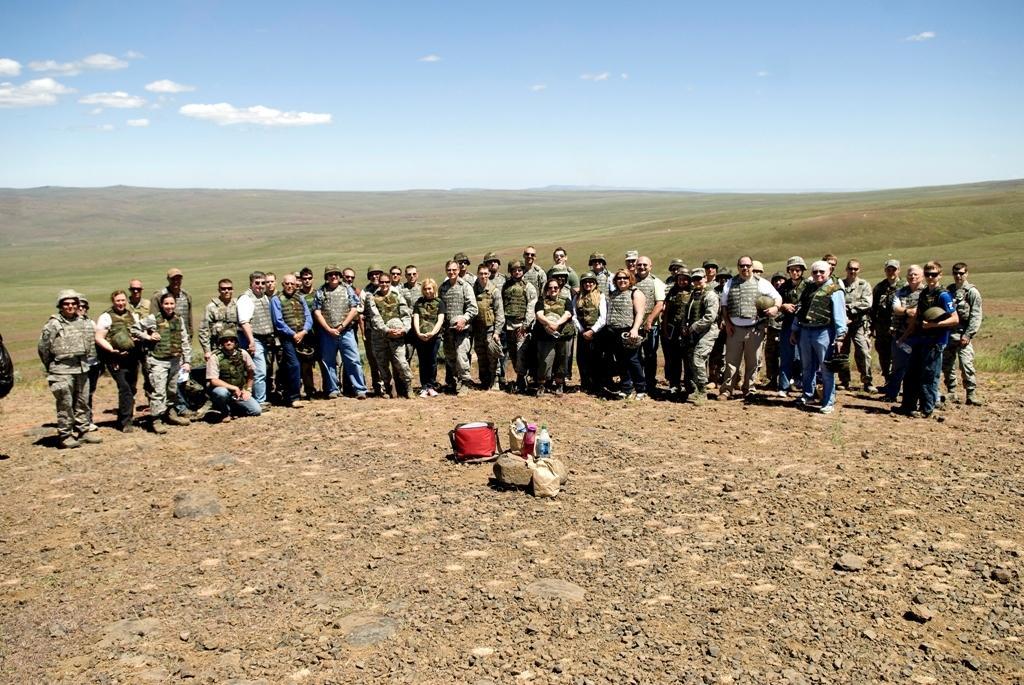In one or two sentences, can you explain what this image depicts? In this image there are group of persons standing and smiling. In the center there are objects on the ground. In the background there is grass on the ground and the sky is cloudy. 